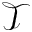Convert formula to latex. <formula><loc_0><loc_0><loc_500><loc_500>\mathcal { T }</formula> 